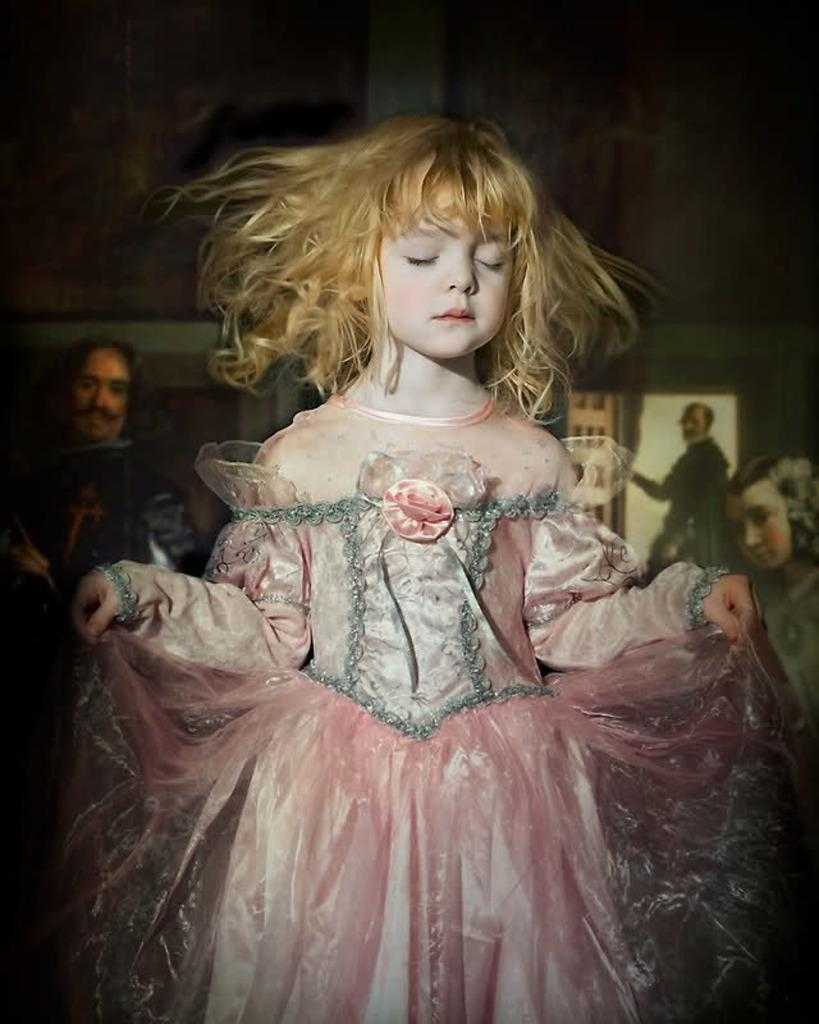Who is the main subject in the image? There is a child in the image. What is the child wearing? The child is wearing a pink and ash color dress. What can be seen in the background of the image? There are painted pictures visible in the background. How would you describe the overall lighting in the image? The background of the image is dark. What type of knowledge does the child possess about the history of slavery in the image? There is no indication in the image that the child possesses any knowledge about the history of slavery, as the image does not depict any related content. 